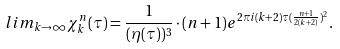Convert formula to latex. <formula><loc_0><loc_0><loc_500><loc_500>l i m _ { k \rightarrow \infty } \chi _ { k } ^ { n } ( \tau ) = \frac { 1 } { ( \eta ( \tau ) ) ^ { 3 } } \cdot ( n + 1 ) e ^ { 2 \pi i ( k + 2 ) \tau ( \frac { n + 1 } { 2 ( k + 2 ) } ) ^ { 2 } } .</formula> 